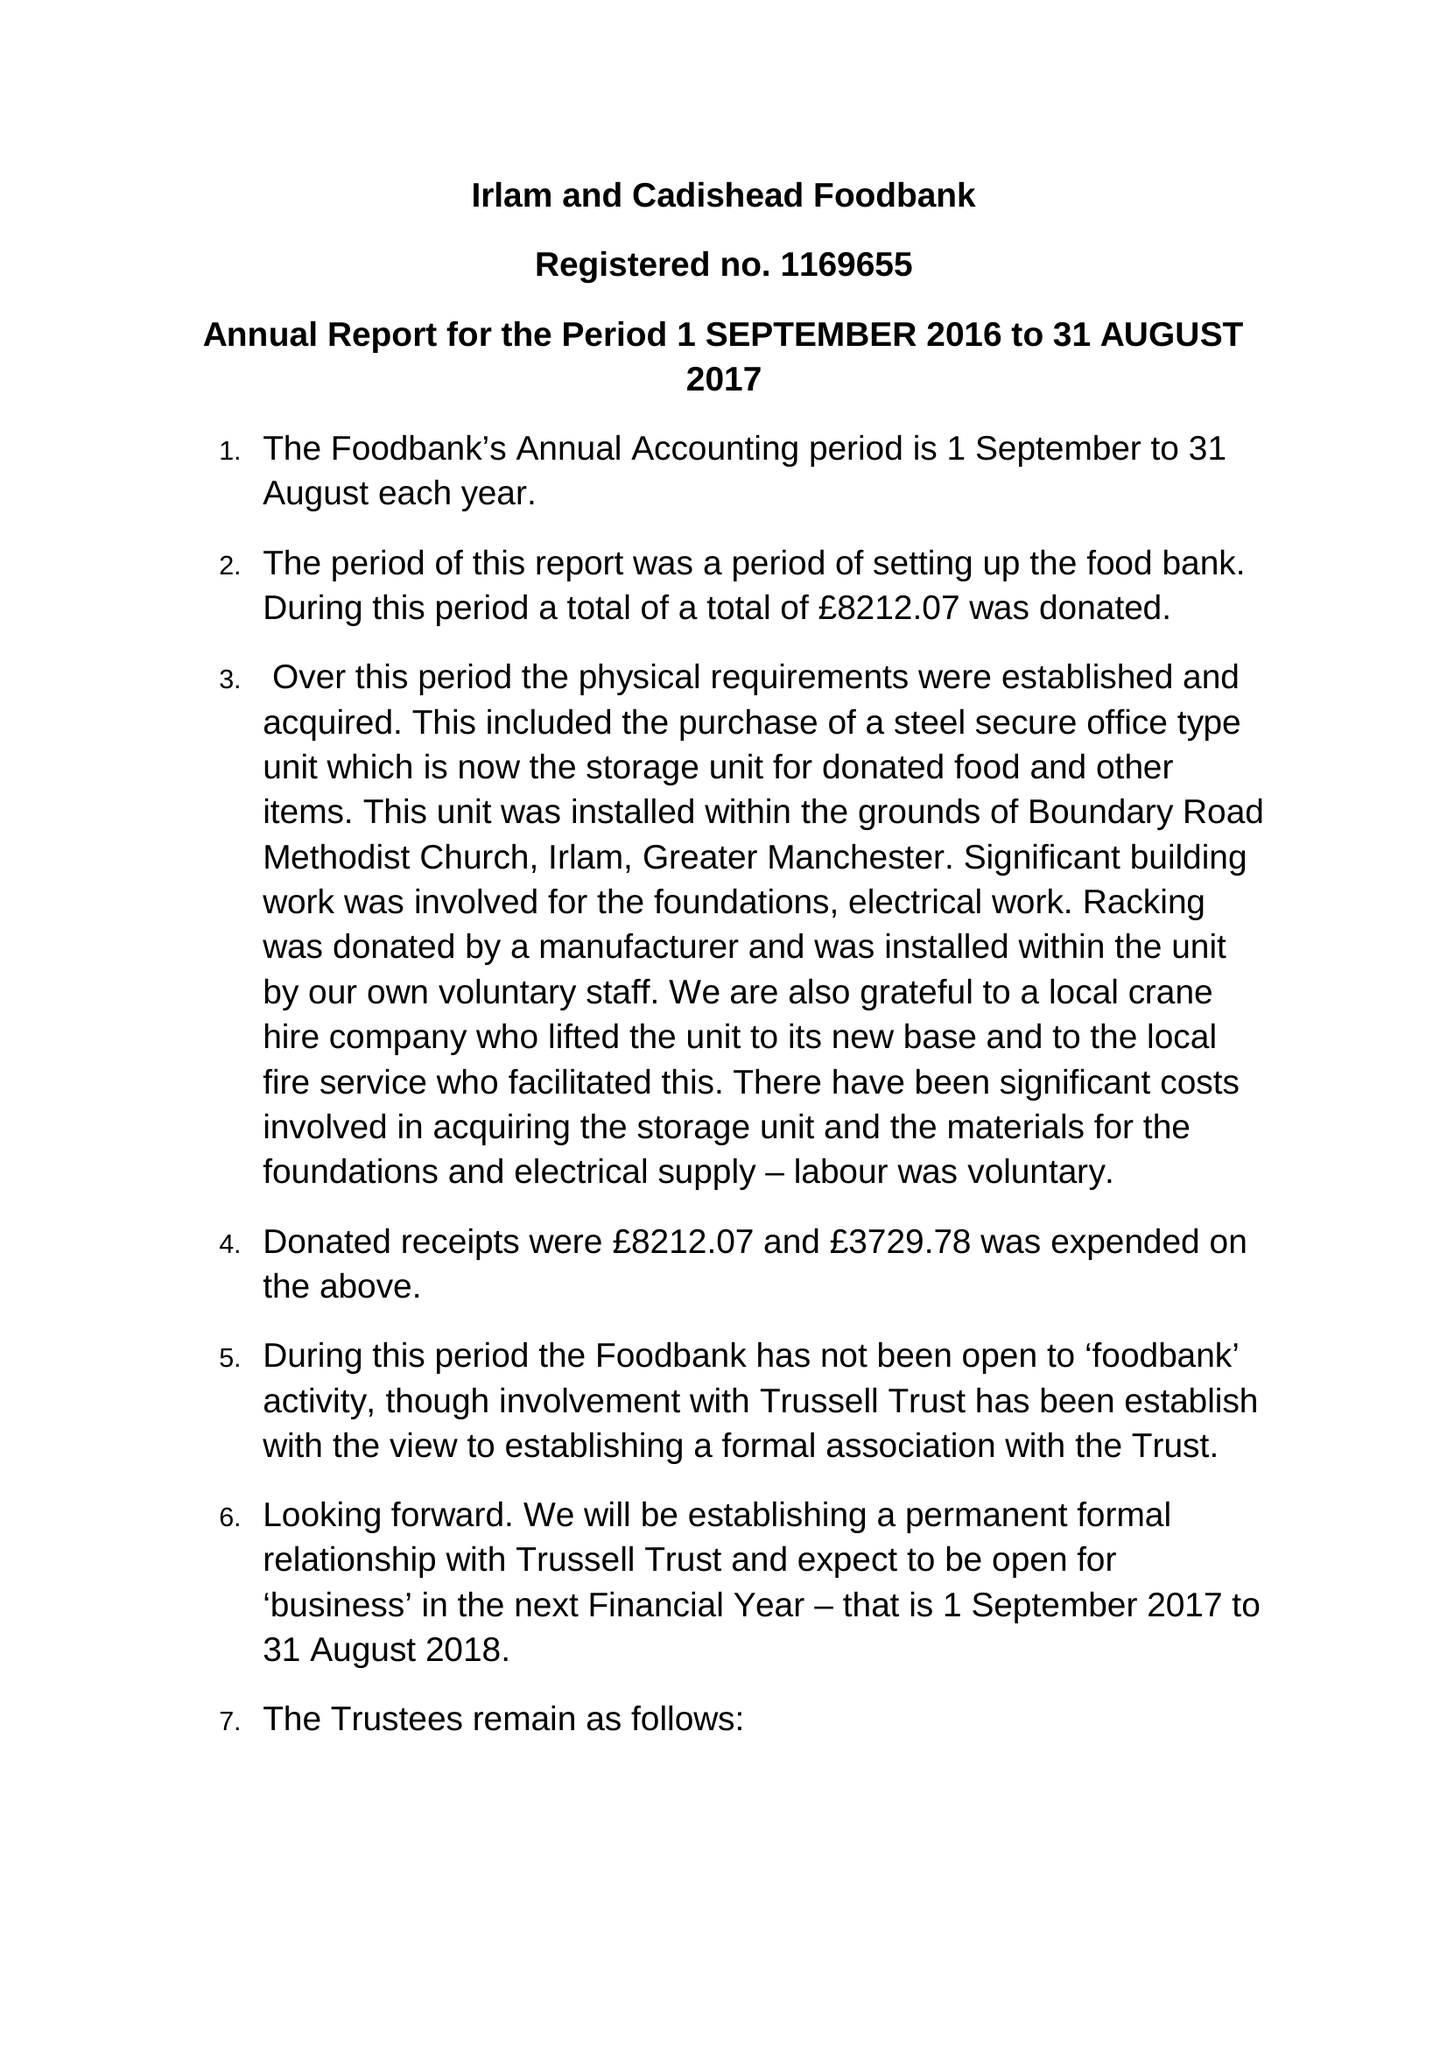What is the value for the spending_annually_in_british_pounds?
Answer the question using a single word or phrase. 3729.00 